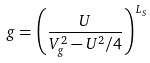Convert formula to latex. <formula><loc_0><loc_0><loc_500><loc_500>g = \left ( \frac { U } { V _ { g } ^ { 2 } - U ^ { 2 } / 4 } \right ) ^ { L _ { S } }</formula> 